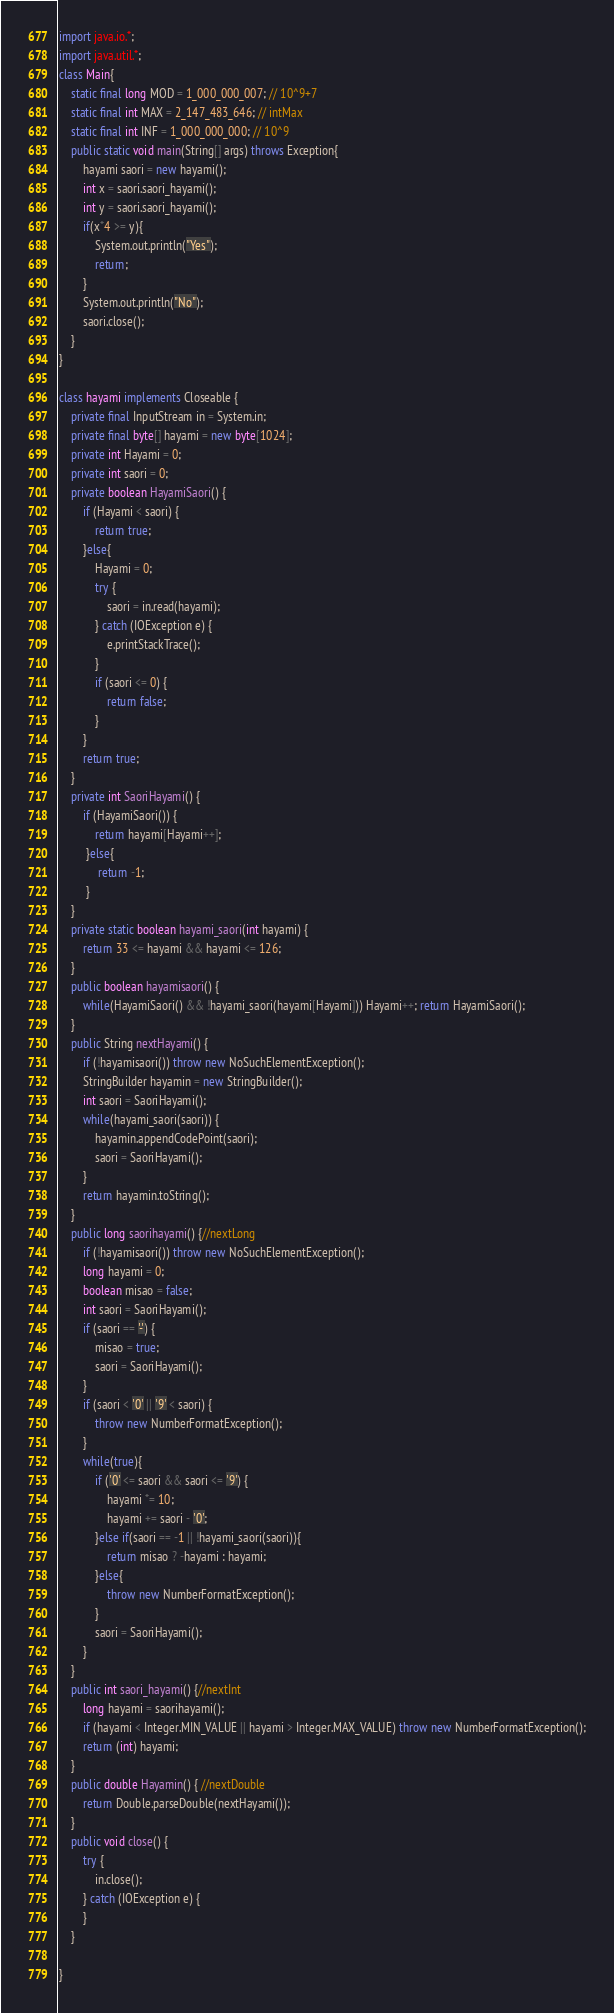Convert code to text. <code><loc_0><loc_0><loc_500><loc_500><_Java_>import java.io.*;
import java.util.*;
class Main{
	static final long MOD = 1_000_000_007; // 10^9+7
	static final int MAX = 2_147_483_646; // intMax 
	static final int INF = 1_000_000_000; // 10^9  
	public static void main(String[] args) throws Exception{
		hayami saori = new hayami();
		int x = saori.saori_hayami();
		int y = saori.saori_hayami();
		if(x*4 >= y){
			System.out.println("Yes");
			return;
		}
		System.out.println("No");
		saori.close();
	}
}

class hayami implements Closeable {
	private final InputStream in = System.in;
	private final byte[] hayami = new byte[1024];
	private int Hayami = 0;
	private int saori = 0;
	private boolean HayamiSaori() {
		if (Hayami < saori) {
			return true;
		}else{
			Hayami = 0;
			try {
				saori = in.read(hayami);
			} catch (IOException e) {
				e.printStackTrace();
			}
			if (saori <= 0) {
				return false;
			}
		}
		return true;
	}
	private int SaoriHayami() { 
		if (HayamiSaori()) {
            return hayami[Hayami++];
         }else{
             return -1;
         }
	}
	private static boolean hayami_saori(int hayami) { 
		return 33 <= hayami && hayami <= 126;
	}
	public boolean hayamisaori() { 
		while(HayamiSaori() && !hayami_saori(hayami[Hayami])) Hayami++; return HayamiSaori();
	}
	public String nextHayami() {
		if (!hayamisaori()) throw new NoSuchElementException();
		StringBuilder hayamin = new StringBuilder();
		int saori = SaoriHayami();
		while(hayami_saori(saori)) {
			hayamin.appendCodePoint(saori);
			saori = SaoriHayami();
		}
		return hayamin.toString();
	}
	public long saorihayami() {//nextLong
		if (!hayamisaori()) throw new NoSuchElementException();
		long hayami = 0;
		boolean misao = false;
		int saori = SaoriHayami();
		if (saori == '-') {
			misao = true;
			saori = SaoriHayami();
		}
		if (saori < '0' || '9' < saori) {
			throw new NumberFormatException();
		}
		while(true){
			if ('0' <= saori && saori <= '9') {
				hayami *= 10;
				hayami += saori - '0';
			}else if(saori == -1 || !hayami_saori(saori)){
				return misao ? -hayami : hayami;
			}else{
				throw new NumberFormatException();
			}
			saori = SaoriHayami();
		}
	}
	public int saori_hayami() {//nextInt
		long hayami = saorihayami();
		if (hayami < Integer.MIN_VALUE || hayami > Integer.MAX_VALUE) throw new NumberFormatException();
		return (int) hayami;
	}
	public double Hayamin() { //nextDouble
		return Double.parseDouble(nextHayami());
	}
	public void close() {
		try {
			in.close();
		} catch (IOException e) {
		}
    }
    
}
</code> 